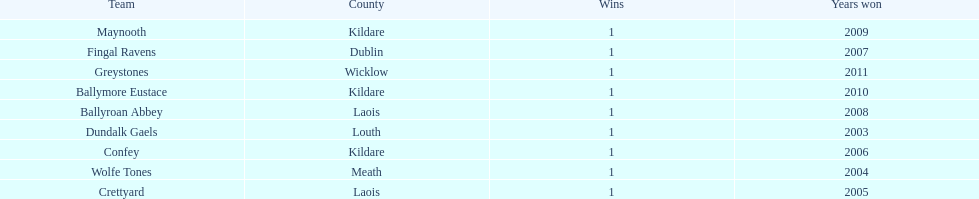What is the years won for each team 2011, 2010, 2009, 2008, 2007, 2006, 2005, 2004, 2003. 